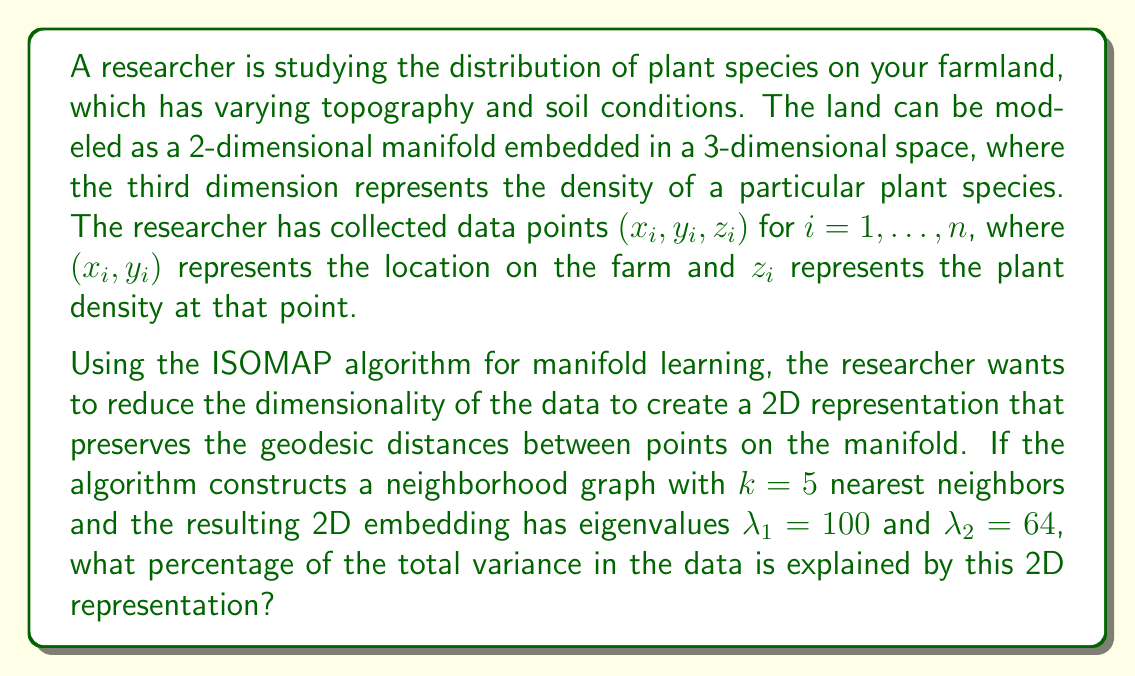Can you answer this question? To solve this problem, we need to understand the ISOMAP algorithm and how it relates to explaining variance in the data. Let's break it down step-by-step:

1) ISOMAP is a nonlinear dimensionality reduction technique that aims to preserve geodesic distances between points on a manifold.

2) The algorithm works by:
   a) Constructing a neighborhood graph
   b) Computing geodesic distances between all pairs of points
   c) Applying Multidimensional Scaling (MDS) to the resulting distance matrix

3) The final step of MDS involves an eigendecomposition of a centered inner product matrix. The resulting eigenvalues represent the amount of variance explained by each dimension in the lower-dimensional embedding.

4) In this case, we have a 2D embedding with eigenvalues $\lambda_1 = 100$ and $\lambda_2 = 64$.

5) To calculate the percentage of total variance explained, we need to:
   a) Sum all eigenvalues to get the total variance
   b) Sum the eigenvalues of the dimensions we're keeping
   c) Divide the sum of kept eigenvalues by the total variance

6) Let's assume that these are the only non-zero eigenvalues (which is often the case in practice). Then:

   Total variance = $\lambda_1 + \lambda_2 = 100 + 64 = 164$

   Variance explained by 2D representation = $100 + 64 = 164$

7) The percentage of variance explained is:

   $$\text{Percentage} = \frac{\text{Variance explained}}{\text{Total variance}} \times 100\% = \frac{164}{164} \times 100\% = 100\%$$

Therefore, this 2D representation explains 100% of the variance in the data.
Answer: 100% 